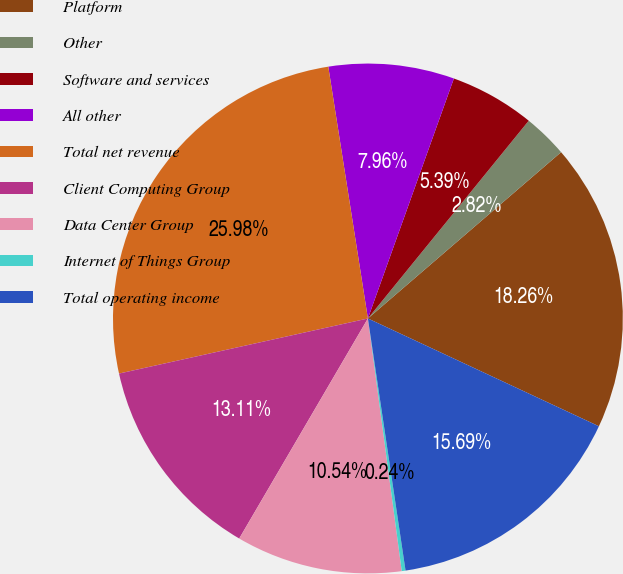<chart> <loc_0><loc_0><loc_500><loc_500><pie_chart><fcel>Platform<fcel>Other<fcel>Software and services<fcel>All other<fcel>Total net revenue<fcel>Client Computing Group<fcel>Data Center Group<fcel>Internet of Things Group<fcel>Total operating income<nl><fcel>18.26%<fcel>2.82%<fcel>5.39%<fcel>7.96%<fcel>25.98%<fcel>13.11%<fcel>10.54%<fcel>0.24%<fcel>15.69%<nl></chart> 